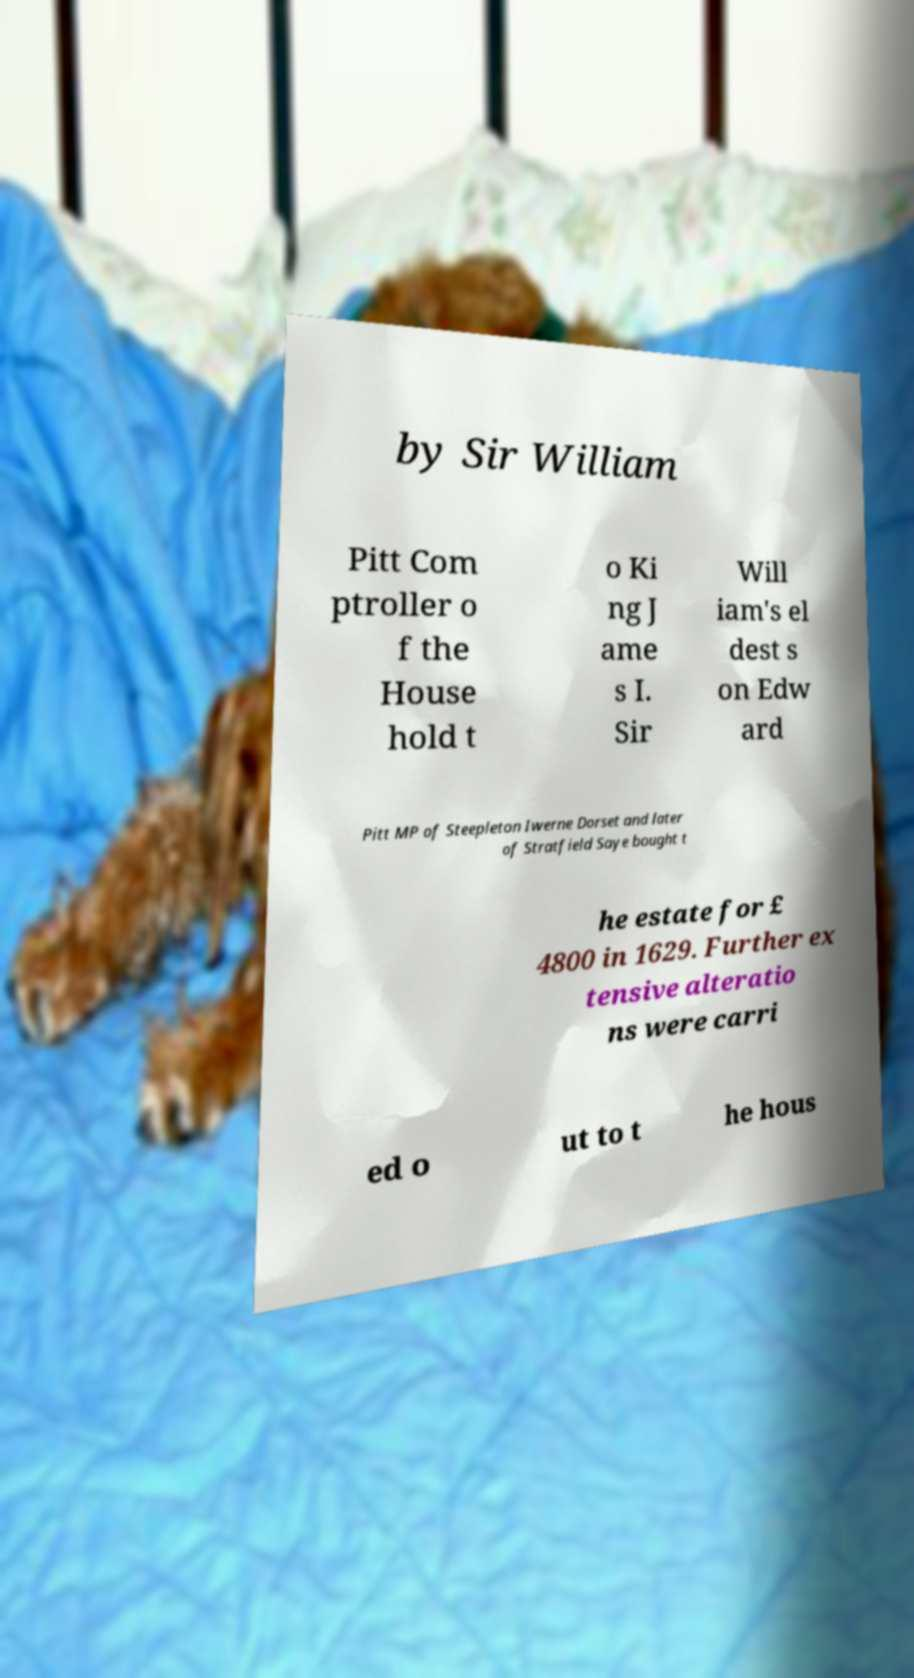What messages or text are displayed in this image? I need them in a readable, typed format. by Sir William Pitt Com ptroller o f the House hold t o Ki ng J ame s I. Sir Will iam's el dest s on Edw ard Pitt MP of Steepleton Iwerne Dorset and later of Stratfield Saye bought t he estate for £ 4800 in 1629. Further ex tensive alteratio ns were carri ed o ut to t he hous 